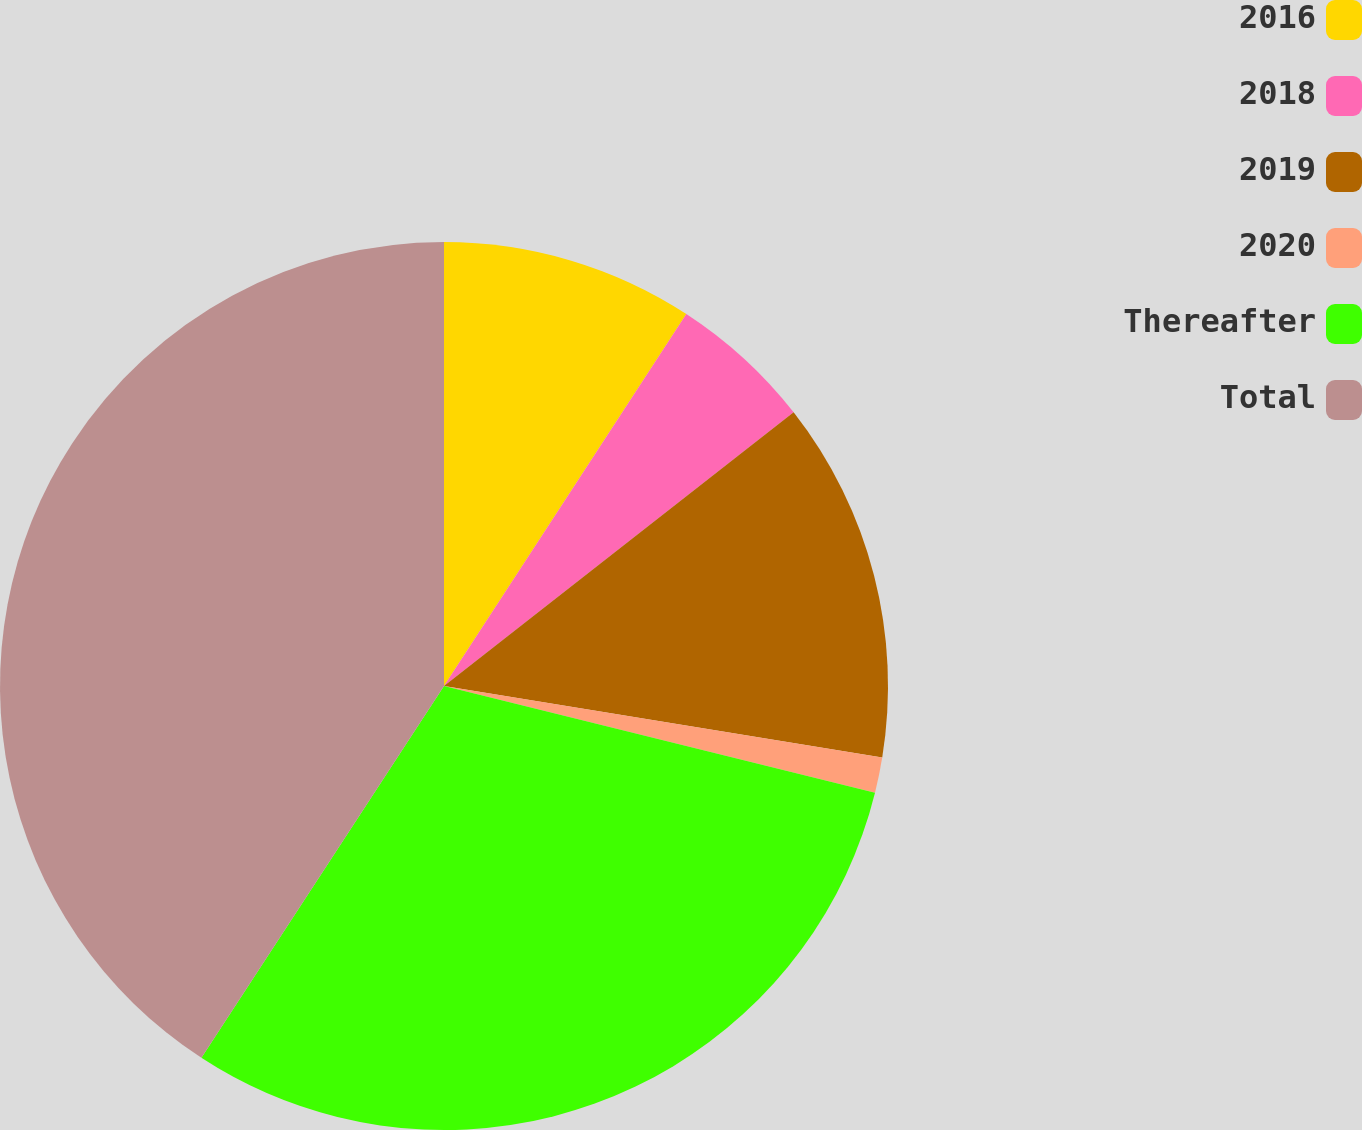Convert chart to OTSL. <chart><loc_0><loc_0><loc_500><loc_500><pie_chart><fcel>2016<fcel>2018<fcel>2019<fcel>2020<fcel>Thereafter<fcel>Total<nl><fcel>9.19%<fcel>5.24%<fcel>13.14%<fcel>1.29%<fcel>30.34%<fcel>40.8%<nl></chart> 